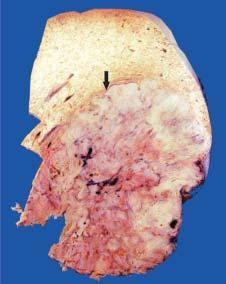does rest of the hepatic parenchyma in the upper part of the picture show many nodules of variable sizes owing to co-existent macronodular cirrhosis?
Answer the question using a single word or phrase. Yes 